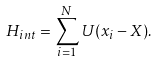Convert formula to latex. <formula><loc_0><loc_0><loc_500><loc_500>H _ { i n t } = \sum _ { i = 1 } ^ { N } U ( x _ { i } - X ) .</formula> 